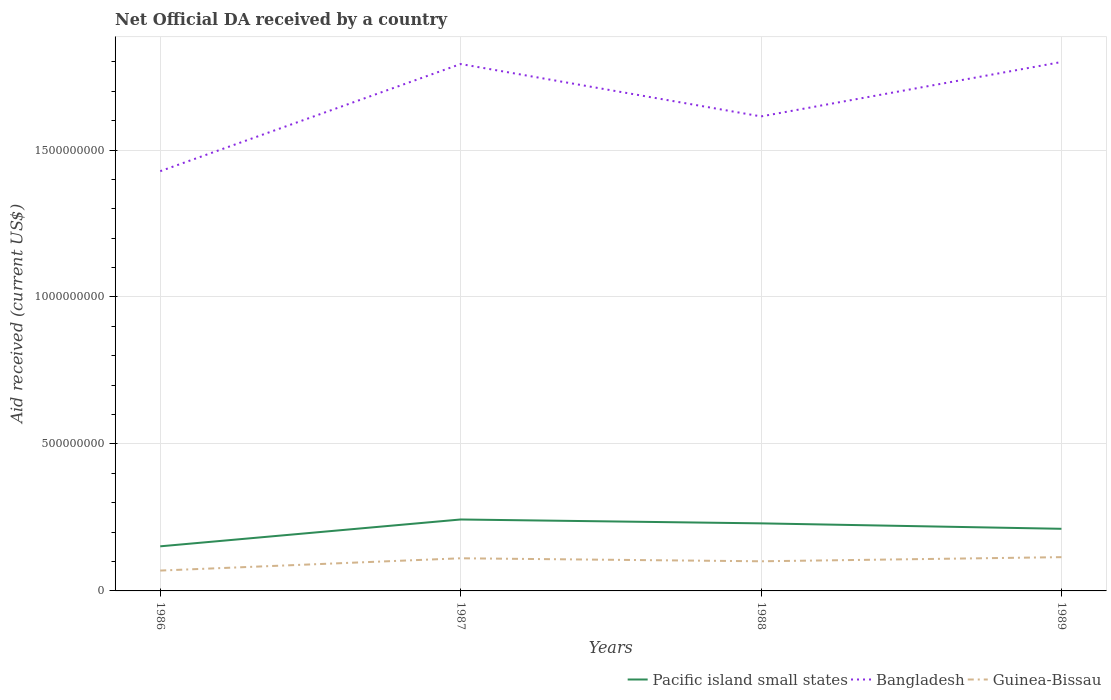How many different coloured lines are there?
Provide a succinct answer. 3. Is the number of lines equal to the number of legend labels?
Offer a terse response. Yes. Across all years, what is the maximum net official development assistance aid received in Guinea-Bissau?
Your response must be concise. 6.92e+07. What is the total net official development assistance aid received in Guinea-Bissau in the graph?
Offer a very short reply. -4.56e+07. What is the difference between the highest and the second highest net official development assistance aid received in Pacific island small states?
Provide a succinct answer. 9.13e+07. What is the difference between the highest and the lowest net official development assistance aid received in Pacific island small states?
Give a very brief answer. 3. Is the net official development assistance aid received in Pacific island small states strictly greater than the net official development assistance aid received in Bangladesh over the years?
Provide a short and direct response. Yes. How many lines are there?
Offer a terse response. 3. How many years are there in the graph?
Your answer should be compact. 4. What is the difference between two consecutive major ticks on the Y-axis?
Offer a terse response. 5.00e+08. Are the values on the major ticks of Y-axis written in scientific E-notation?
Keep it short and to the point. No. Does the graph contain any zero values?
Your answer should be compact. No. How many legend labels are there?
Provide a short and direct response. 3. What is the title of the graph?
Your answer should be compact. Net Official DA received by a country. What is the label or title of the X-axis?
Provide a short and direct response. Years. What is the label or title of the Y-axis?
Give a very brief answer. Aid received (current US$). What is the Aid received (current US$) of Pacific island small states in 1986?
Your response must be concise. 1.52e+08. What is the Aid received (current US$) of Bangladesh in 1986?
Your answer should be compact. 1.43e+09. What is the Aid received (current US$) of Guinea-Bissau in 1986?
Ensure brevity in your answer.  6.92e+07. What is the Aid received (current US$) of Pacific island small states in 1987?
Give a very brief answer. 2.43e+08. What is the Aid received (current US$) in Bangladesh in 1987?
Ensure brevity in your answer.  1.79e+09. What is the Aid received (current US$) in Guinea-Bissau in 1987?
Give a very brief answer. 1.11e+08. What is the Aid received (current US$) in Pacific island small states in 1988?
Your answer should be compact. 2.30e+08. What is the Aid received (current US$) in Bangladesh in 1988?
Your response must be concise. 1.61e+09. What is the Aid received (current US$) of Guinea-Bissau in 1988?
Offer a terse response. 1.01e+08. What is the Aid received (current US$) in Pacific island small states in 1989?
Provide a short and direct response. 2.11e+08. What is the Aid received (current US$) in Bangladesh in 1989?
Your response must be concise. 1.80e+09. What is the Aid received (current US$) of Guinea-Bissau in 1989?
Provide a short and direct response. 1.15e+08. Across all years, what is the maximum Aid received (current US$) of Pacific island small states?
Keep it short and to the point. 2.43e+08. Across all years, what is the maximum Aid received (current US$) in Bangladesh?
Your response must be concise. 1.80e+09. Across all years, what is the maximum Aid received (current US$) of Guinea-Bissau?
Provide a succinct answer. 1.15e+08. Across all years, what is the minimum Aid received (current US$) of Pacific island small states?
Give a very brief answer. 1.52e+08. Across all years, what is the minimum Aid received (current US$) in Bangladesh?
Provide a short and direct response. 1.43e+09. Across all years, what is the minimum Aid received (current US$) of Guinea-Bissau?
Give a very brief answer. 6.92e+07. What is the total Aid received (current US$) of Pacific island small states in the graph?
Your response must be concise. 8.36e+08. What is the total Aid received (current US$) of Bangladesh in the graph?
Offer a terse response. 6.63e+09. What is the total Aid received (current US$) of Guinea-Bissau in the graph?
Ensure brevity in your answer.  3.96e+08. What is the difference between the Aid received (current US$) of Pacific island small states in 1986 and that in 1987?
Ensure brevity in your answer.  -9.13e+07. What is the difference between the Aid received (current US$) in Bangladesh in 1986 and that in 1987?
Give a very brief answer. -3.65e+08. What is the difference between the Aid received (current US$) of Guinea-Bissau in 1986 and that in 1987?
Keep it short and to the point. -4.18e+07. What is the difference between the Aid received (current US$) of Pacific island small states in 1986 and that in 1988?
Ensure brevity in your answer.  -7.81e+07. What is the difference between the Aid received (current US$) in Bangladesh in 1986 and that in 1988?
Ensure brevity in your answer.  -1.86e+08. What is the difference between the Aid received (current US$) in Guinea-Bissau in 1986 and that in 1988?
Offer a very short reply. -3.16e+07. What is the difference between the Aid received (current US$) in Pacific island small states in 1986 and that in 1989?
Provide a succinct answer. -5.96e+07. What is the difference between the Aid received (current US$) in Bangladesh in 1986 and that in 1989?
Offer a terse response. -3.71e+08. What is the difference between the Aid received (current US$) of Guinea-Bissau in 1986 and that in 1989?
Make the answer very short. -4.56e+07. What is the difference between the Aid received (current US$) in Pacific island small states in 1987 and that in 1988?
Your response must be concise. 1.32e+07. What is the difference between the Aid received (current US$) of Bangladesh in 1987 and that in 1988?
Your response must be concise. 1.78e+08. What is the difference between the Aid received (current US$) of Guinea-Bissau in 1987 and that in 1988?
Give a very brief answer. 1.02e+07. What is the difference between the Aid received (current US$) in Pacific island small states in 1987 and that in 1989?
Provide a succinct answer. 3.17e+07. What is the difference between the Aid received (current US$) of Bangladesh in 1987 and that in 1989?
Offer a terse response. -6.89e+06. What is the difference between the Aid received (current US$) in Guinea-Bissau in 1987 and that in 1989?
Provide a short and direct response. -3.83e+06. What is the difference between the Aid received (current US$) of Pacific island small states in 1988 and that in 1989?
Keep it short and to the point. 1.85e+07. What is the difference between the Aid received (current US$) in Bangladesh in 1988 and that in 1989?
Your answer should be compact. -1.85e+08. What is the difference between the Aid received (current US$) of Guinea-Bissau in 1988 and that in 1989?
Offer a very short reply. -1.41e+07. What is the difference between the Aid received (current US$) in Pacific island small states in 1986 and the Aid received (current US$) in Bangladesh in 1987?
Make the answer very short. -1.64e+09. What is the difference between the Aid received (current US$) in Pacific island small states in 1986 and the Aid received (current US$) in Guinea-Bissau in 1987?
Provide a succinct answer. 4.07e+07. What is the difference between the Aid received (current US$) of Bangladesh in 1986 and the Aid received (current US$) of Guinea-Bissau in 1987?
Provide a short and direct response. 1.32e+09. What is the difference between the Aid received (current US$) of Pacific island small states in 1986 and the Aid received (current US$) of Bangladesh in 1988?
Your answer should be compact. -1.46e+09. What is the difference between the Aid received (current US$) of Pacific island small states in 1986 and the Aid received (current US$) of Guinea-Bissau in 1988?
Make the answer very short. 5.09e+07. What is the difference between the Aid received (current US$) in Bangladesh in 1986 and the Aid received (current US$) in Guinea-Bissau in 1988?
Provide a short and direct response. 1.33e+09. What is the difference between the Aid received (current US$) in Pacific island small states in 1986 and the Aid received (current US$) in Bangladesh in 1989?
Give a very brief answer. -1.65e+09. What is the difference between the Aid received (current US$) of Pacific island small states in 1986 and the Aid received (current US$) of Guinea-Bissau in 1989?
Give a very brief answer. 3.68e+07. What is the difference between the Aid received (current US$) in Bangladesh in 1986 and the Aid received (current US$) in Guinea-Bissau in 1989?
Provide a succinct answer. 1.31e+09. What is the difference between the Aid received (current US$) in Pacific island small states in 1987 and the Aid received (current US$) in Bangladesh in 1988?
Your answer should be compact. -1.37e+09. What is the difference between the Aid received (current US$) of Pacific island small states in 1987 and the Aid received (current US$) of Guinea-Bissau in 1988?
Your response must be concise. 1.42e+08. What is the difference between the Aid received (current US$) in Bangladesh in 1987 and the Aid received (current US$) in Guinea-Bissau in 1988?
Your answer should be compact. 1.69e+09. What is the difference between the Aid received (current US$) in Pacific island small states in 1987 and the Aid received (current US$) in Bangladesh in 1989?
Give a very brief answer. -1.56e+09. What is the difference between the Aid received (current US$) in Pacific island small states in 1987 and the Aid received (current US$) in Guinea-Bissau in 1989?
Your response must be concise. 1.28e+08. What is the difference between the Aid received (current US$) of Bangladesh in 1987 and the Aid received (current US$) of Guinea-Bissau in 1989?
Offer a terse response. 1.68e+09. What is the difference between the Aid received (current US$) in Pacific island small states in 1988 and the Aid received (current US$) in Bangladesh in 1989?
Give a very brief answer. -1.57e+09. What is the difference between the Aid received (current US$) in Pacific island small states in 1988 and the Aid received (current US$) in Guinea-Bissau in 1989?
Make the answer very short. 1.15e+08. What is the difference between the Aid received (current US$) in Bangladesh in 1988 and the Aid received (current US$) in Guinea-Bissau in 1989?
Provide a short and direct response. 1.50e+09. What is the average Aid received (current US$) of Pacific island small states per year?
Provide a short and direct response. 2.09e+08. What is the average Aid received (current US$) in Bangladesh per year?
Your response must be concise. 1.66e+09. What is the average Aid received (current US$) in Guinea-Bissau per year?
Offer a terse response. 9.90e+07. In the year 1986, what is the difference between the Aid received (current US$) in Pacific island small states and Aid received (current US$) in Bangladesh?
Offer a very short reply. -1.28e+09. In the year 1986, what is the difference between the Aid received (current US$) in Pacific island small states and Aid received (current US$) in Guinea-Bissau?
Your answer should be compact. 8.25e+07. In the year 1986, what is the difference between the Aid received (current US$) of Bangladesh and Aid received (current US$) of Guinea-Bissau?
Your response must be concise. 1.36e+09. In the year 1987, what is the difference between the Aid received (current US$) in Pacific island small states and Aid received (current US$) in Bangladesh?
Offer a terse response. -1.55e+09. In the year 1987, what is the difference between the Aid received (current US$) in Pacific island small states and Aid received (current US$) in Guinea-Bissau?
Provide a succinct answer. 1.32e+08. In the year 1987, what is the difference between the Aid received (current US$) in Bangladesh and Aid received (current US$) in Guinea-Bissau?
Give a very brief answer. 1.68e+09. In the year 1988, what is the difference between the Aid received (current US$) of Pacific island small states and Aid received (current US$) of Bangladesh?
Make the answer very short. -1.38e+09. In the year 1988, what is the difference between the Aid received (current US$) in Pacific island small states and Aid received (current US$) in Guinea-Bissau?
Make the answer very short. 1.29e+08. In the year 1988, what is the difference between the Aid received (current US$) of Bangladesh and Aid received (current US$) of Guinea-Bissau?
Make the answer very short. 1.51e+09. In the year 1989, what is the difference between the Aid received (current US$) in Pacific island small states and Aid received (current US$) in Bangladesh?
Your answer should be very brief. -1.59e+09. In the year 1989, what is the difference between the Aid received (current US$) of Pacific island small states and Aid received (current US$) of Guinea-Bissau?
Keep it short and to the point. 9.65e+07. In the year 1989, what is the difference between the Aid received (current US$) in Bangladesh and Aid received (current US$) in Guinea-Bissau?
Give a very brief answer. 1.68e+09. What is the ratio of the Aid received (current US$) in Pacific island small states in 1986 to that in 1987?
Your answer should be very brief. 0.62. What is the ratio of the Aid received (current US$) in Bangladesh in 1986 to that in 1987?
Keep it short and to the point. 0.8. What is the ratio of the Aid received (current US$) in Guinea-Bissau in 1986 to that in 1987?
Your answer should be very brief. 0.62. What is the ratio of the Aid received (current US$) in Pacific island small states in 1986 to that in 1988?
Provide a short and direct response. 0.66. What is the ratio of the Aid received (current US$) of Bangladesh in 1986 to that in 1988?
Your answer should be very brief. 0.88. What is the ratio of the Aid received (current US$) in Guinea-Bissau in 1986 to that in 1988?
Your response must be concise. 0.69. What is the ratio of the Aid received (current US$) of Pacific island small states in 1986 to that in 1989?
Give a very brief answer. 0.72. What is the ratio of the Aid received (current US$) of Bangladesh in 1986 to that in 1989?
Give a very brief answer. 0.79. What is the ratio of the Aid received (current US$) in Guinea-Bissau in 1986 to that in 1989?
Your answer should be very brief. 0.6. What is the ratio of the Aid received (current US$) in Pacific island small states in 1987 to that in 1988?
Keep it short and to the point. 1.06. What is the ratio of the Aid received (current US$) in Bangladesh in 1987 to that in 1988?
Offer a very short reply. 1.11. What is the ratio of the Aid received (current US$) in Guinea-Bissau in 1987 to that in 1988?
Ensure brevity in your answer.  1.1. What is the ratio of the Aid received (current US$) of Pacific island small states in 1987 to that in 1989?
Your answer should be very brief. 1.15. What is the ratio of the Aid received (current US$) in Guinea-Bissau in 1987 to that in 1989?
Keep it short and to the point. 0.97. What is the ratio of the Aid received (current US$) in Pacific island small states in 1988 to that in 1989?
Make the answer very short. 1.09. What is the ratio of the Aid received (current US$) of Bangladesh in 1988 to that in 1989?
Make the answer very short. 0.9. What is the ratio of the Aid received (current US$) of Guinea-Bissau in 1988 to that in 1989?
Provide a short and direct response. 0.88. What is the difference between the highest and the second highest Aid received (current US$) in Pacific island small states?
Keep it short and to the point. 1.32e+07. What is the difference between the highest and the second highest Aid received (current US$) of Bangladesh?
Provide a short and direct response. 6.89e+06. What is the difference between the highest and the second highest Aid received (current US$) of Guinea-Bissau?
Make the answer very short. 3.83e+06. What is the difference between the highest and the lowest Aid received (current US$) in Pacific island small states?
Your answer should be very brief. 9.13e+07. What is the difference between the highest and the lowest Aid received (current US$) in Bangladesh?
Your answer should be very brief. 3.71e+08. What is the difference between the highest and the lowest Aid received (current US$) of Guinea-Bissau?
Ensure brevity in your answer.  4.56e+07. 